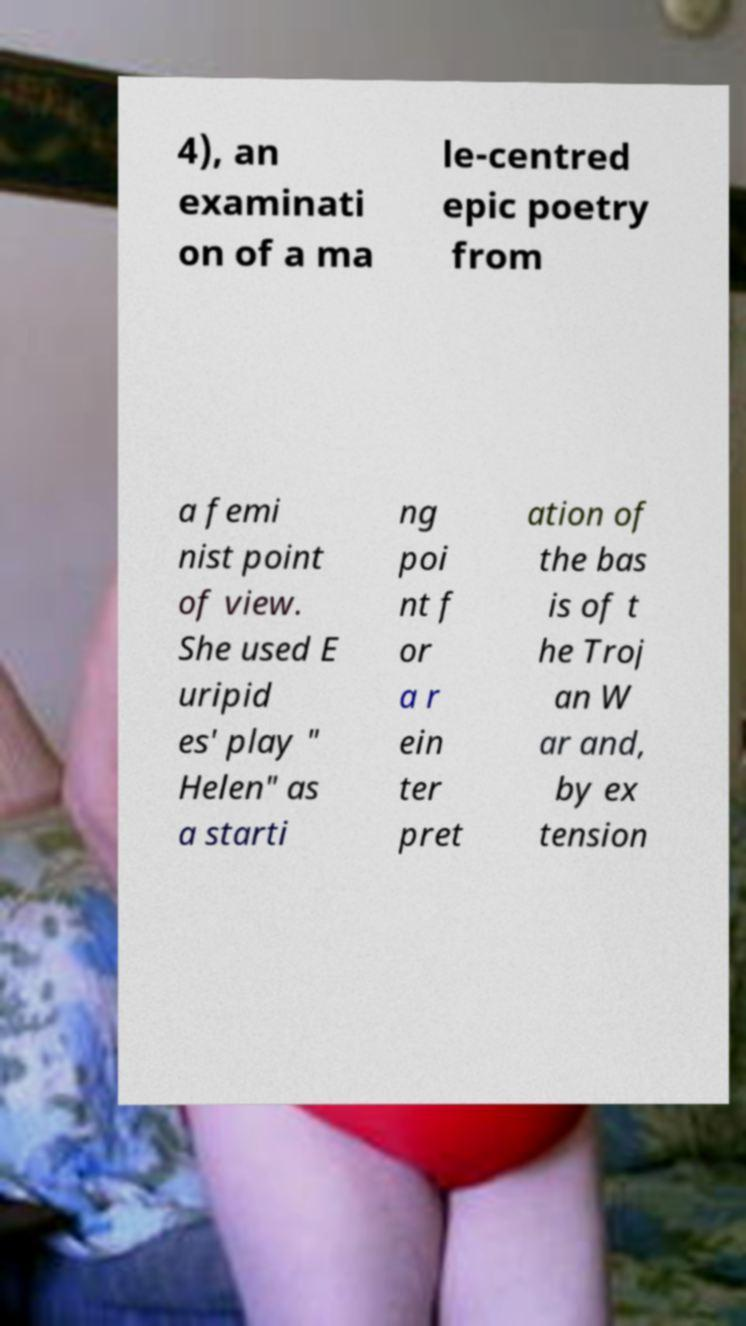Could you assist in decoding the text presented in this image and type it out clearly? 4), an examinati on of a ma le-centred epic poetry from a femi nist point of view. She used E uripid es' play " Helen" as a starti ng poi nt f or a r ein ter pret ation of the bas is of t he Troj an W ar and, by ex tension 